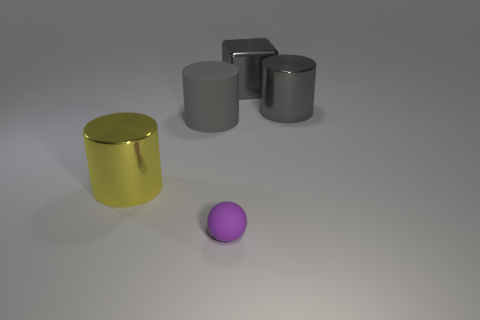Add 1 tiny matte objects. How many objects exist? 6 Subtract all blocks. How many objects are left? 4 Subtract all metallic things. Subtract all large cyan metallic objects. How many objects are left? 2 Add 2 yellow shiny things. How many yellow shiny things are left? 3 Add 4 gray shiny cylinders. How many gray shiny cylinders exist? 5 Subtract 0 brown blocks. How many objects are left? 5 